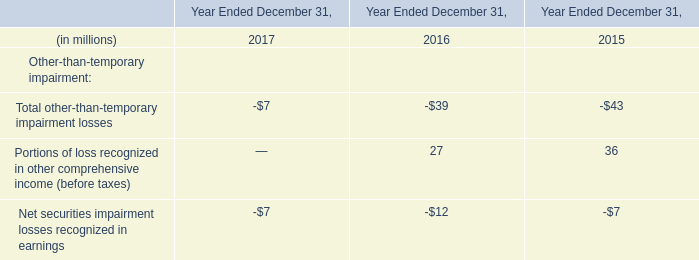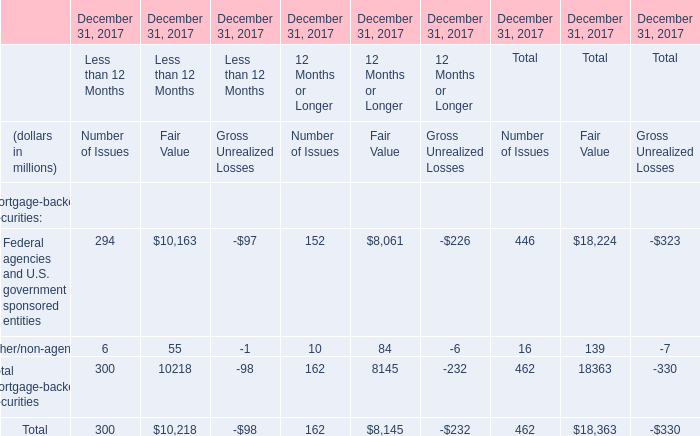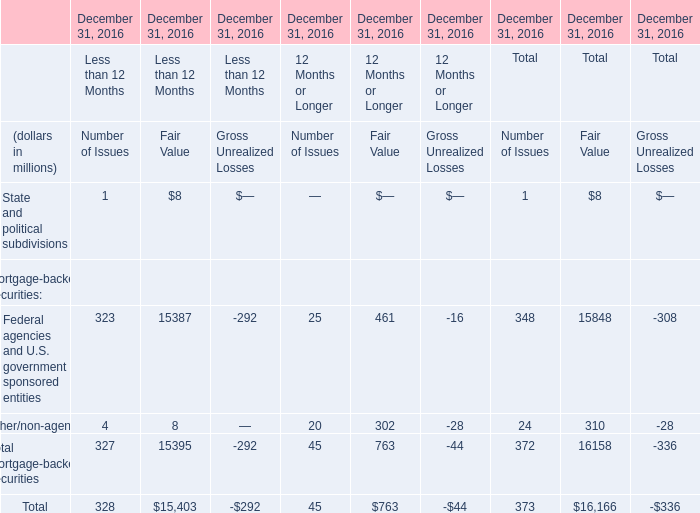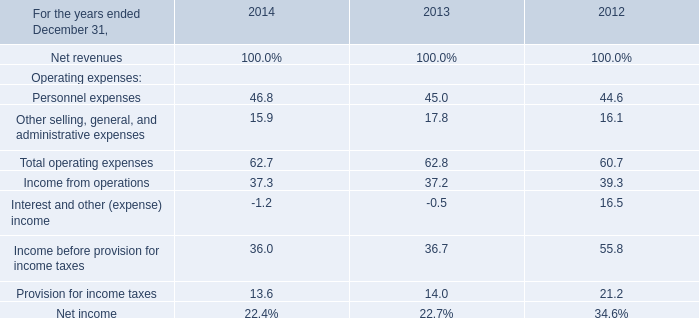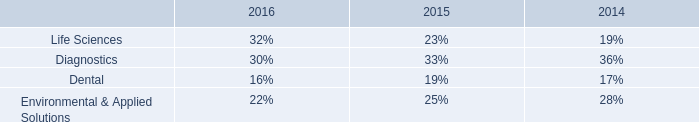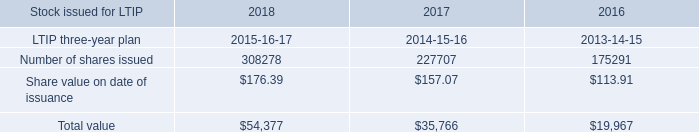Which element exceeds 1 % of total in Fair Value? 
Answer: Federal agencies and U.S. government sponsored entities, Other/non-agency. 